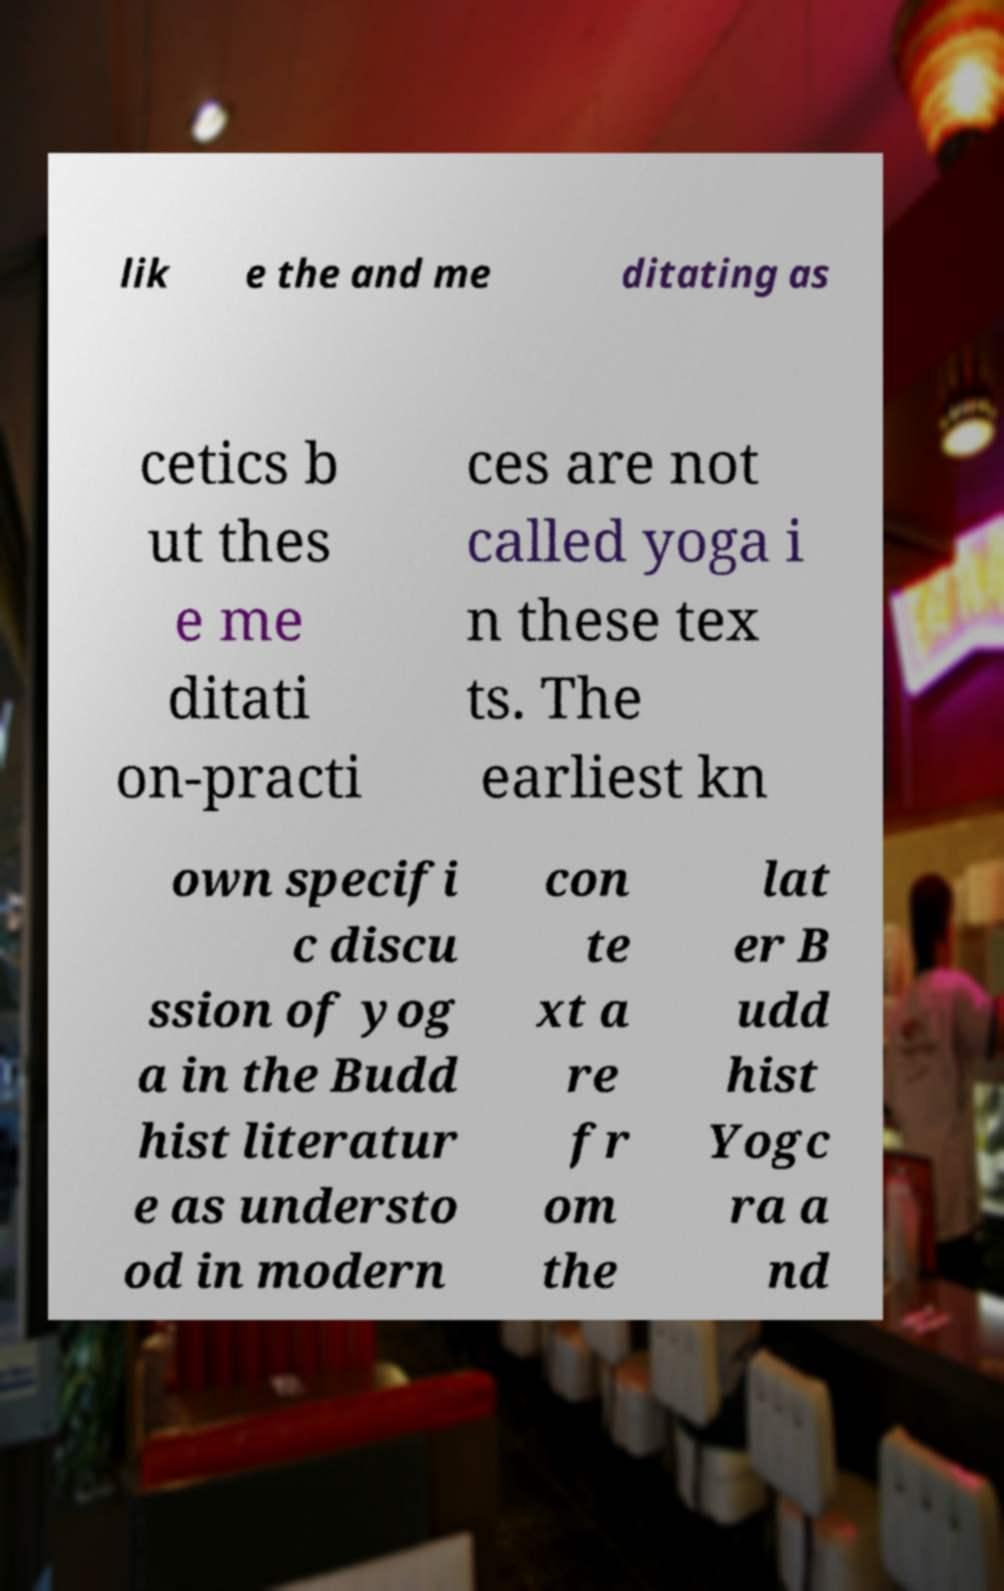There's text embedded in this image that I need extracted. Can you transcribe it verbatim? lik e the and me ditating as cetics b ut thes e me ditati on-practi ces are not called yoga i n these tex ts. The earliest kn own specifi c discu ssion of yog a in the Budd hist literatur e as understo od in modern con te xt a re fr om the lat er B udd hist Yogc ra a nd 